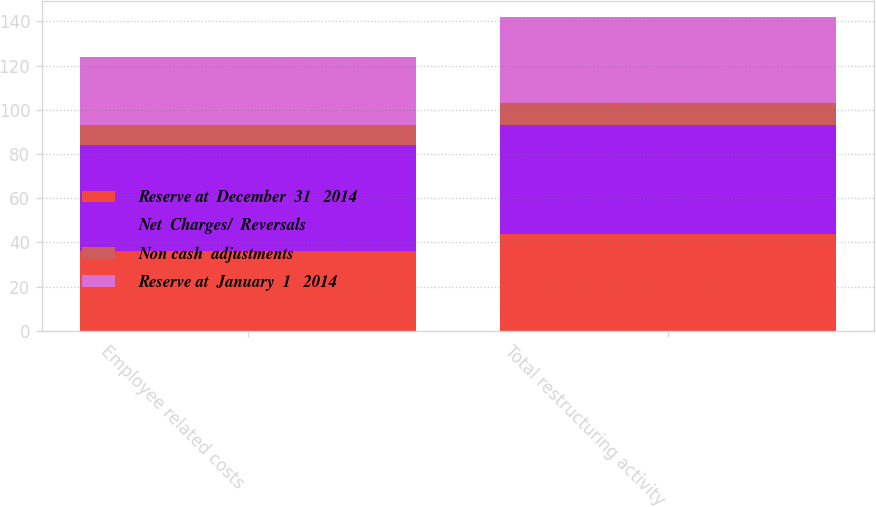Convert chart. <chart><loc_0><loc_0><loc_500><loc_500><stacked_bar_chart><ecel><fcel>Employee related costs<fcel>Total restructuring activity<nl><fcel>Reserve at  December  31   2014<fcel>36<fcel>44<nl><fcel>Net  Charges/  Reversals<fcel>48<fcel>49<nl><fcel>Non cash  adjustments<fcel>9<fcel>10<nl><fcel>Reserve at  January  1   2014<fcel>31<fcel>39<nl></chart> 